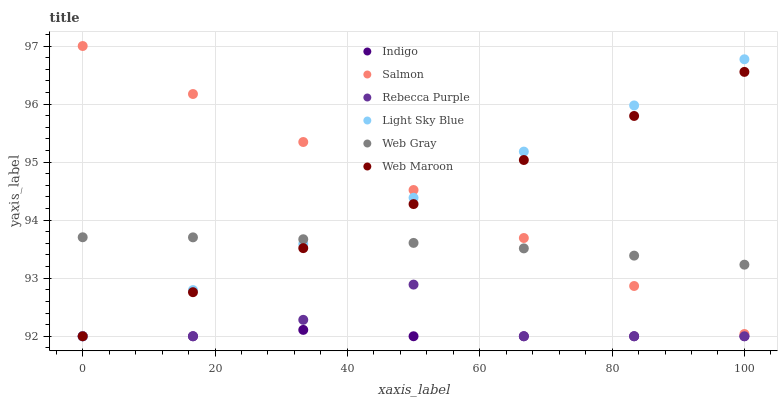Does Indigo have the minimum area under the curve?
Answer yes or no. Yes. Does Salmon have the maximum area under the curve?
Answer yes or no. Yes. Does Web Maroon have the minimum area under the curve?
Answer yes or no. No. Does Web Maroon have the maximum area under the curve?
Answer yes or no. No. Is Light Sky Blue the smoothest?
Answer yes or no. Yes. Is Rebecca Purple the roughest?
Answer yes or no. Yes. Is Indigo the smoothest?
Answer yes or no. No. Is Indigo the roughest?
Answer yes or no. No. Does Indigo have the lowest value?
Answer yes or no. Yes. Does Salmon have the lowest value?
Answer yes or no. No. Does Salmon have the highest value?
Answer yes or no. Yes. Does Web Maroon have the highest value?
Answer yes or no. No. Is Rebecca Purple less than Salmon?
Answer yes or no. Yes. Is Salmon greater than Rebecca Purple?
Answer yes or no. Yes. Does Rebecca Purple intersect Light Sky Blue?
Answer yes or no. Yes. Is Rebecca Purple less than Light Sky Blue?
Answer yes or no. No. Is Rebecca Purple greater than Light Sky Blue?
Answer yes or no. No. Does Rebecca Purple intersect Salmon?
Answer yes or no. No. 